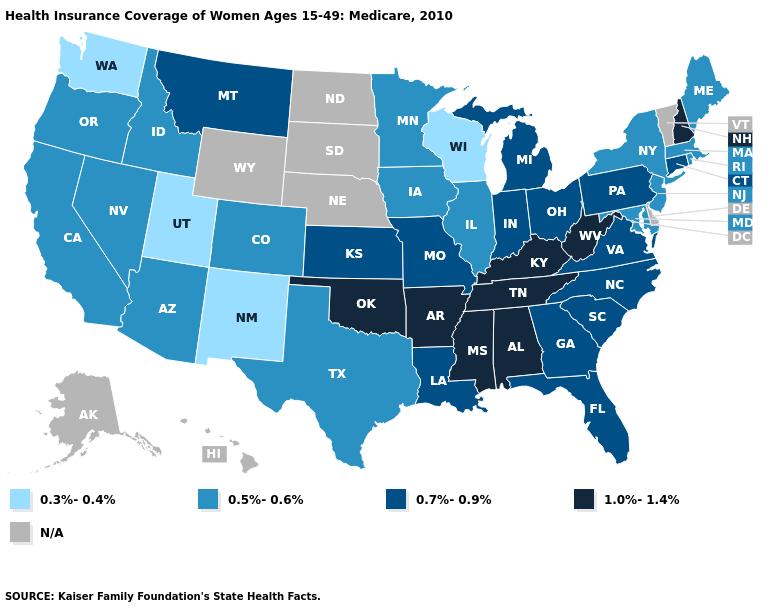Name the states that have a value in the range N/A?
Be succinct. Alaska, Delaware, Hawaii, Nebraska, North Dakota, South Dakota, Vermont, Wyoming. What is the value of Florida?
Short answer required. 0.7%-0.9%. Does Florida have the highest value in the South?
Be succinct. No. What is the value of Iowa?
Quick response, please. 0.5%-0.6%. Does the map have missing data?
Concise answer only. Yes. Name the states that have a value in the range N/A?
Keep it brief. Alaska, Delaware, Hawaii, Nebraska, North Dakota, South Dakota, Vermont, Wyoming. What is the highest value in the USA?
Quick response, please. 1.0%-1.4%. Among the states that border Tennessee , which have the lowest value?
Write a very short answer. Georgia, Missouri, North Carolina, Virginia. What is the value of Maryland?
Answer briefly. 0.5%-0.6%. What is the highest value in states that border Rhode Island?
Keep it brief. 0.7%-0.9%. What is the value of Texas?
Short answer required. 0.5%-0.6%. Among the states that border Louisiana , which have the highest value?
Give a very brief answer. Arkansas, Mississippi. Which states hav the highest value in the West?
Be succinct. Montana. Which states have the lowest value in the USA?
Short answer required. New Mexico, Utah, Washington, Wisconsin. Does the map have missing data?
Answer briefly. Yes. 